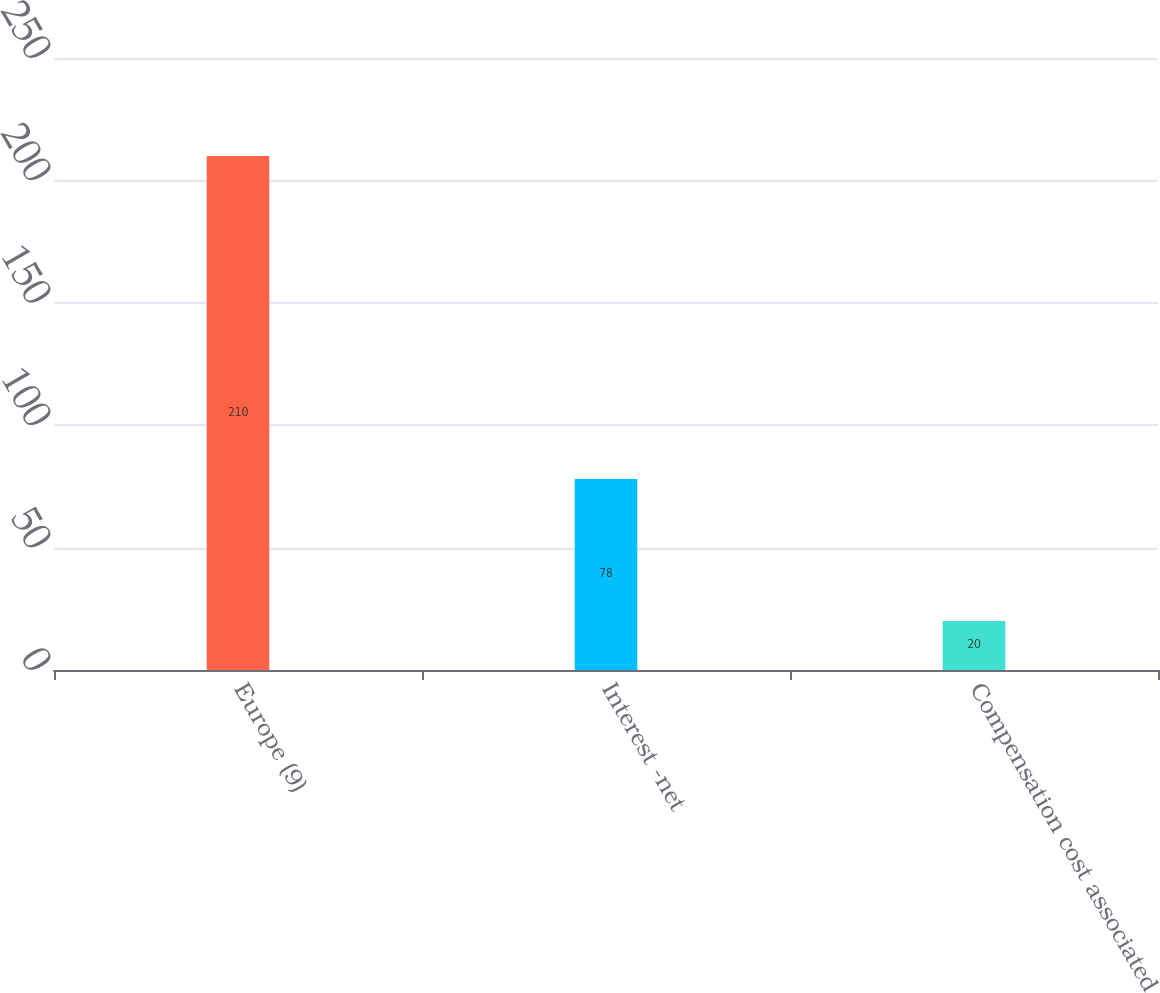Convert chart. <chart><loc_0><loc_0><loc_500><loc_500><bar_chart><fcel>Europe (9)<fcel>Interest -net<fcel>Compensation cost associated<nl><fcel>210<fcel>78<fcel>20<nl></chart> 